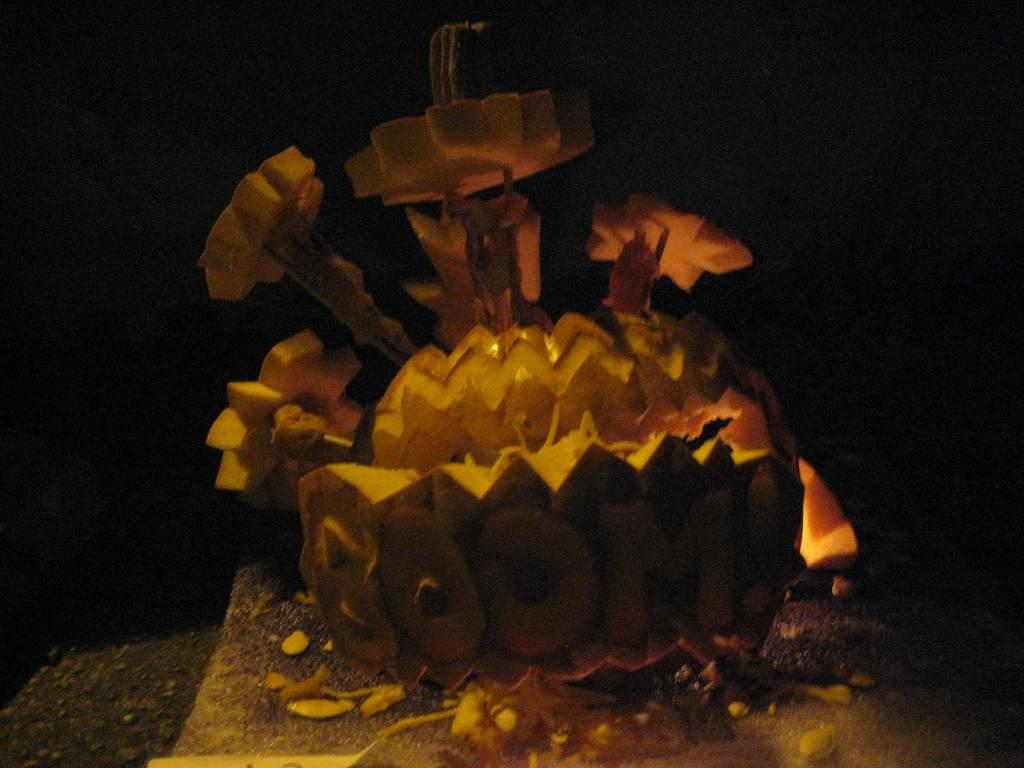What is the main subject of the image? The main subject of the image is a carved fruit. What is a unique feature of the carved fruit? There is text written on the fruit. How many eyes can be seen on the fruit in the image? There are no eyes visible on the fruit in the image. 